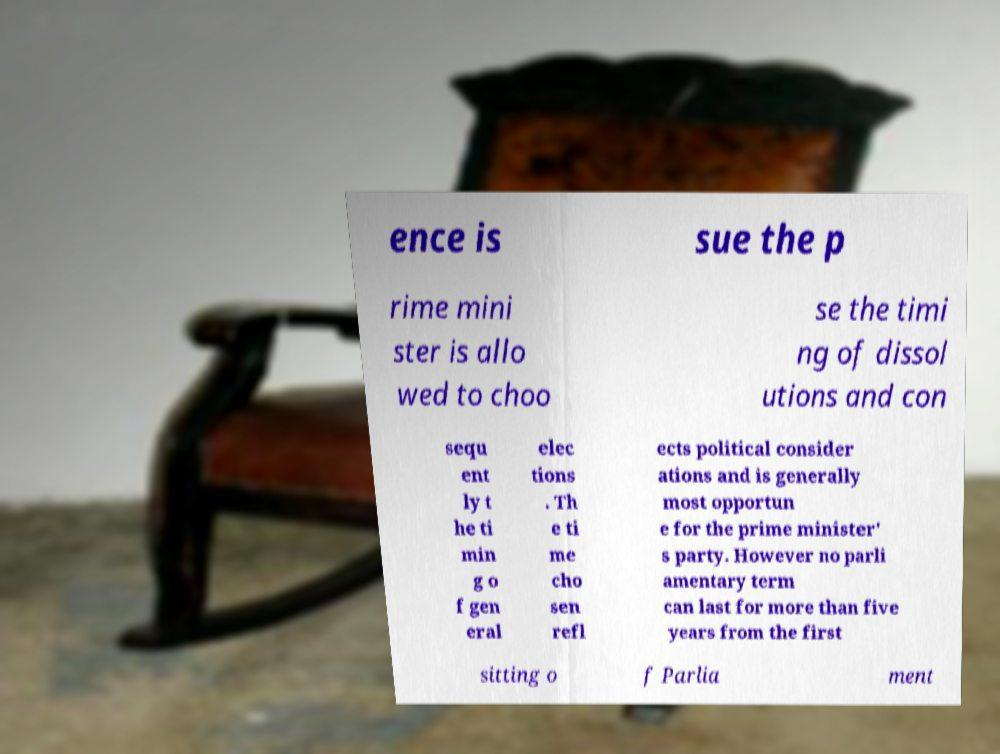Could you extract and type out the text from this image? ence is sue the p rime mini ster is allo wed to choo se the timi ng of dissol utions and con sequ ent ly t he ti min g o f gen eral elec tions . Th e ti me cho sen refl ects political consider ations and is generally most opportun e for the prime minister' s party. However no parli amentary term can last for more than five years from the first sitting o f Parlia ment 